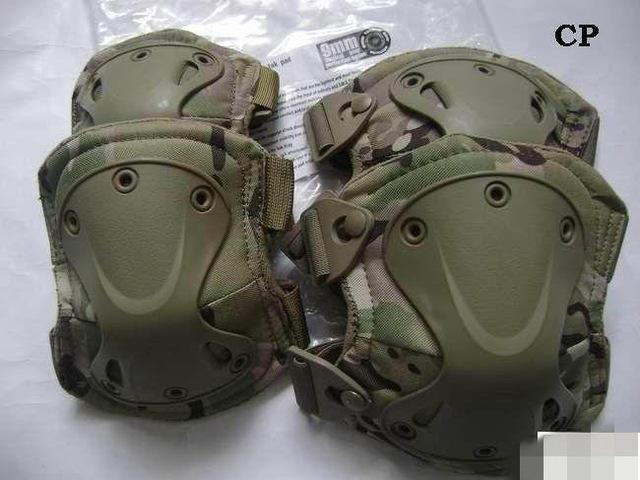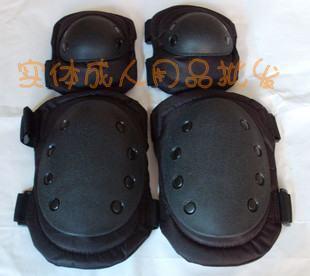The first image is the image on the left, the second image is the image on the right. Given the left and right images, does the statement "The right image contains exactly two pairs of black pads arranged with one pair above the other." hold true? Answer yes or no. Yes. The first image is the image on the left, the second image is the image on the right. Considering the images on both sides, is "Some knee pads have a camouflage design." valid? Answer yes or no. Yes. 